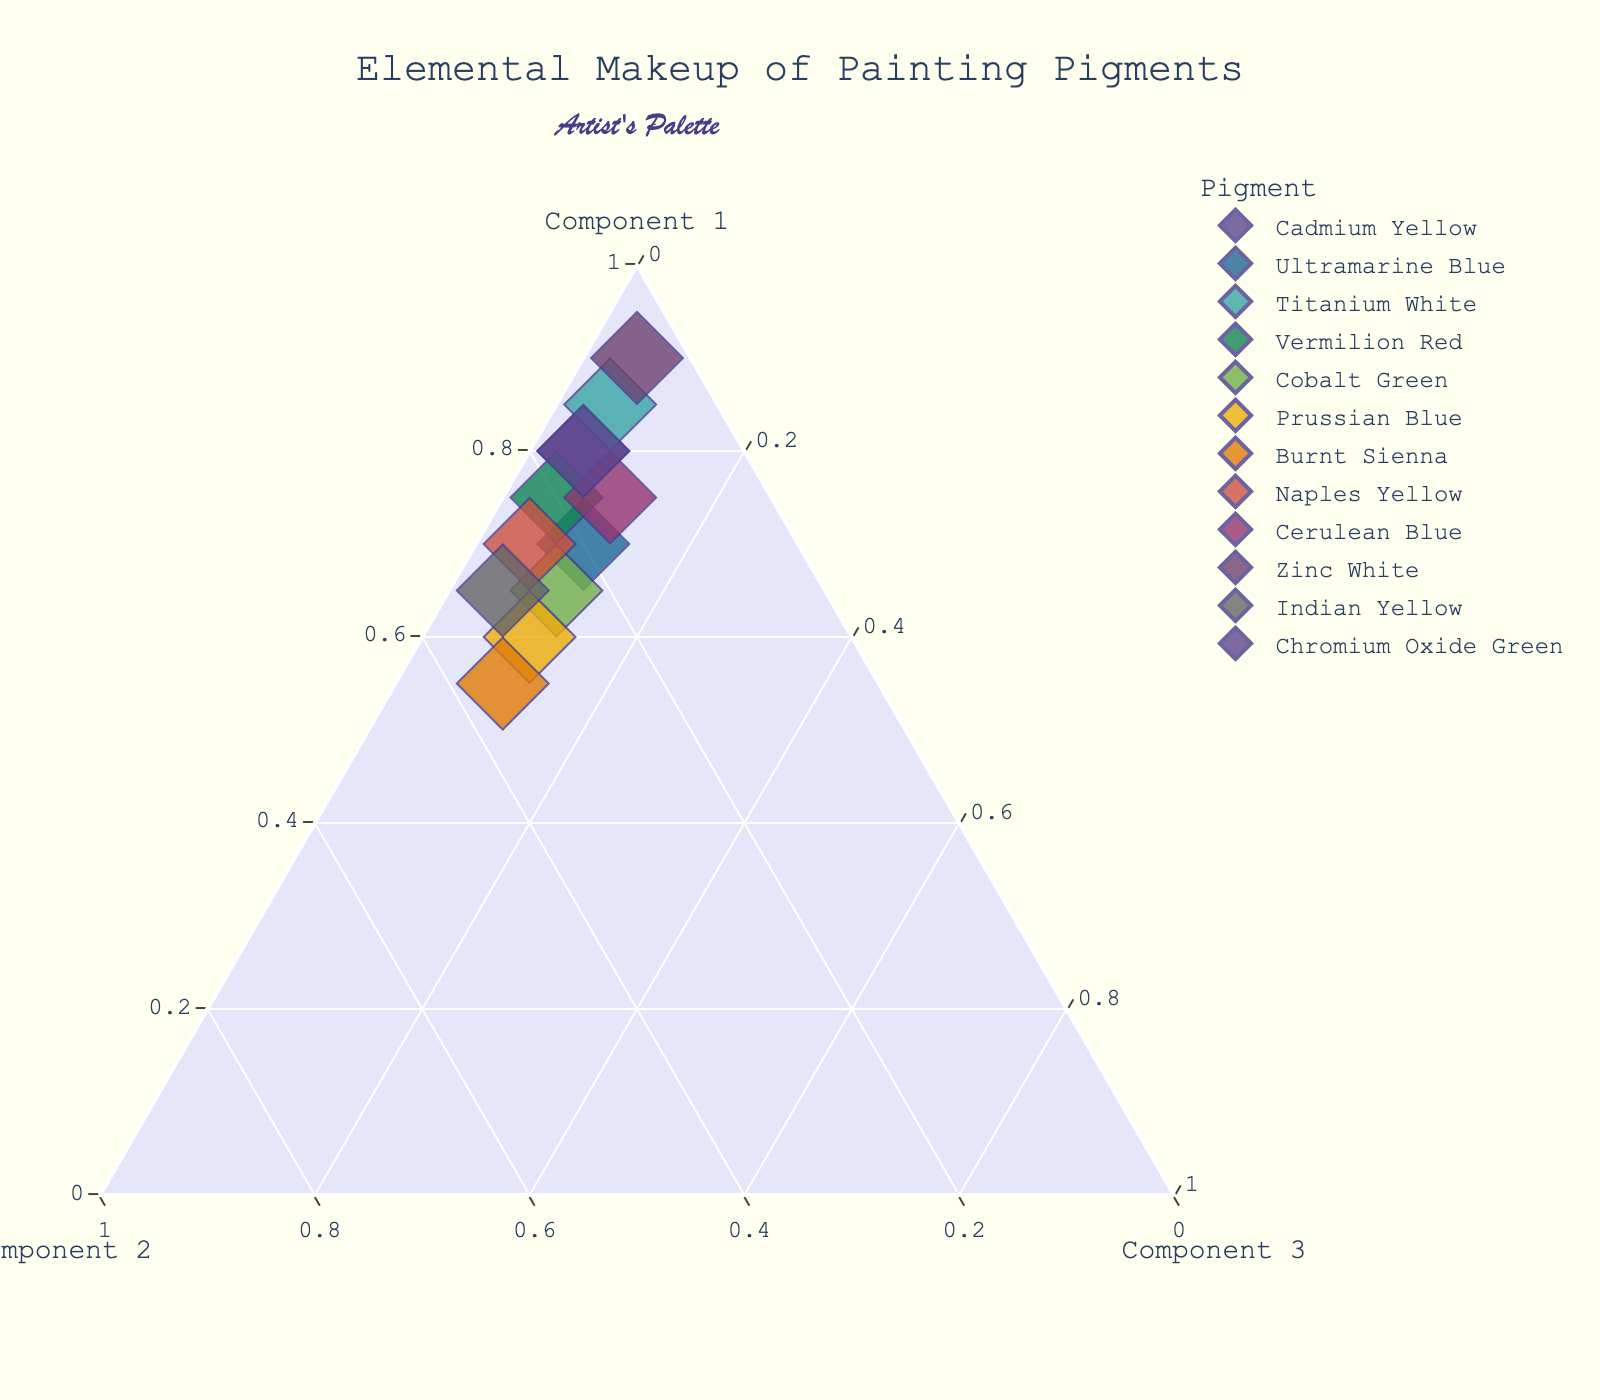How many pigments are displayed in the plot? We can find the number of pigments by counting the data points in the plot, each colored and labeled by its name. There are 12 distinct pigments listed in the dataset.
Answer: 12 Which pigment shows the highest proportion of Component 1? The proportion of Component 1 for each pigment is plotted on the ternary plot's Component 1 axis. Zinc White has the highest Component 1 percentage at 90%.
Answer: Zinc White Compare the total values of Cadmium Yellow and Ultramarine Blue. Which one is larger? The total values for each pigment can be calculated as the sum of Component 1, Component 2, and Component 3. Both totals are provided in the dataset: Cadmium Yellow (80 + 15 + 5 = 100) and Ultramarine Blue (70 + 20 + 10 = 100). Since both totals are equal, neither is larger.
Answer: Both are equal Which pigment has the smallest proportion of Component 2 and what is that proportion? By looking at the data points and proportions on the ternary plot, Zinc White has the smallest proportion of Component 2 at 5%.
Answer: Zinc White, 5% What is the average proportion of Component 3 across all pigments? To find the average, we sum up the Component 3 proportions and divide by the number of pigments. The sum of Component 3 proportions is 85 (5+10+5+5+10+10+10+5+10+5+5+5). Dividing by 12, (85 / 12) ≈ 7.08.
Answer: 7.08 Which pigment is positioned nearest to the Component 1 axis? A pigment nearest to the Component 1 axis will have high percentages of Component 2 and Component 3. Prussian Blue is closest to the Component 1 axis as it has a lower Component 1 proportion (60%) compared to others.
Answer: Prussian Blue Is there a pigment where Component 3 proportion is exactly twice that of Component 2? If yes, which one? We need to find a pigment where the plotting indicates the proportion of Component 3 is twice Component 2. None of the given pigments fit this criteria when examining their plotted proportions.
Answer: No Compare the ratios of Component 1 to the sum of Component 2 and Component 3 for Titanium White and Vermilion Red. Which is higher? Titanium White ratio: 85 / (10 + 5) = 85 / 15 ≈ 5.67; Vermilion Red ratio: 75 / (20 + 5) = 75 / 25 = 3.0. Thus, Titanium White has a higher ratio.
Answer: Titanium White 